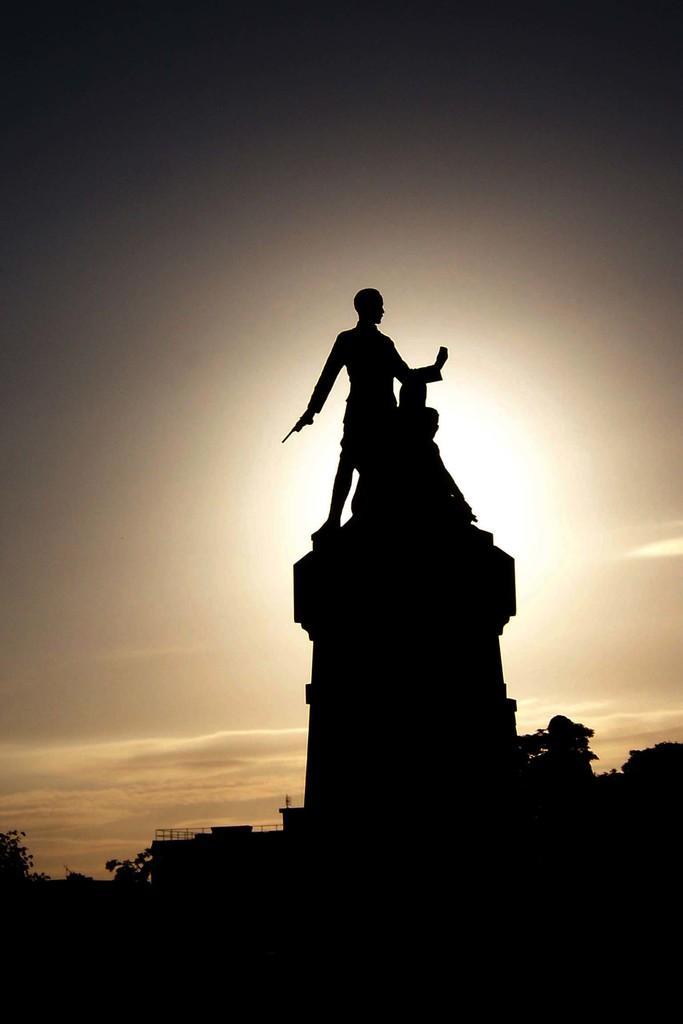Please provide a concise description of this image. In this image I can see two persons statues. In the background I can see few trees and the sky is in white and gray color. 